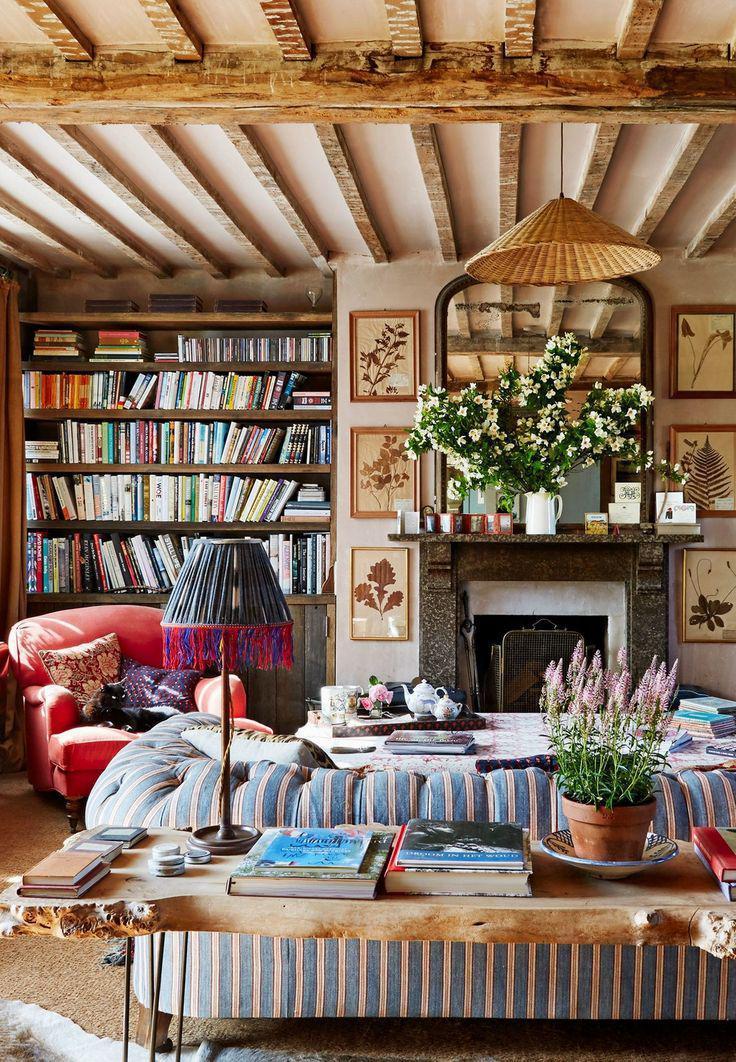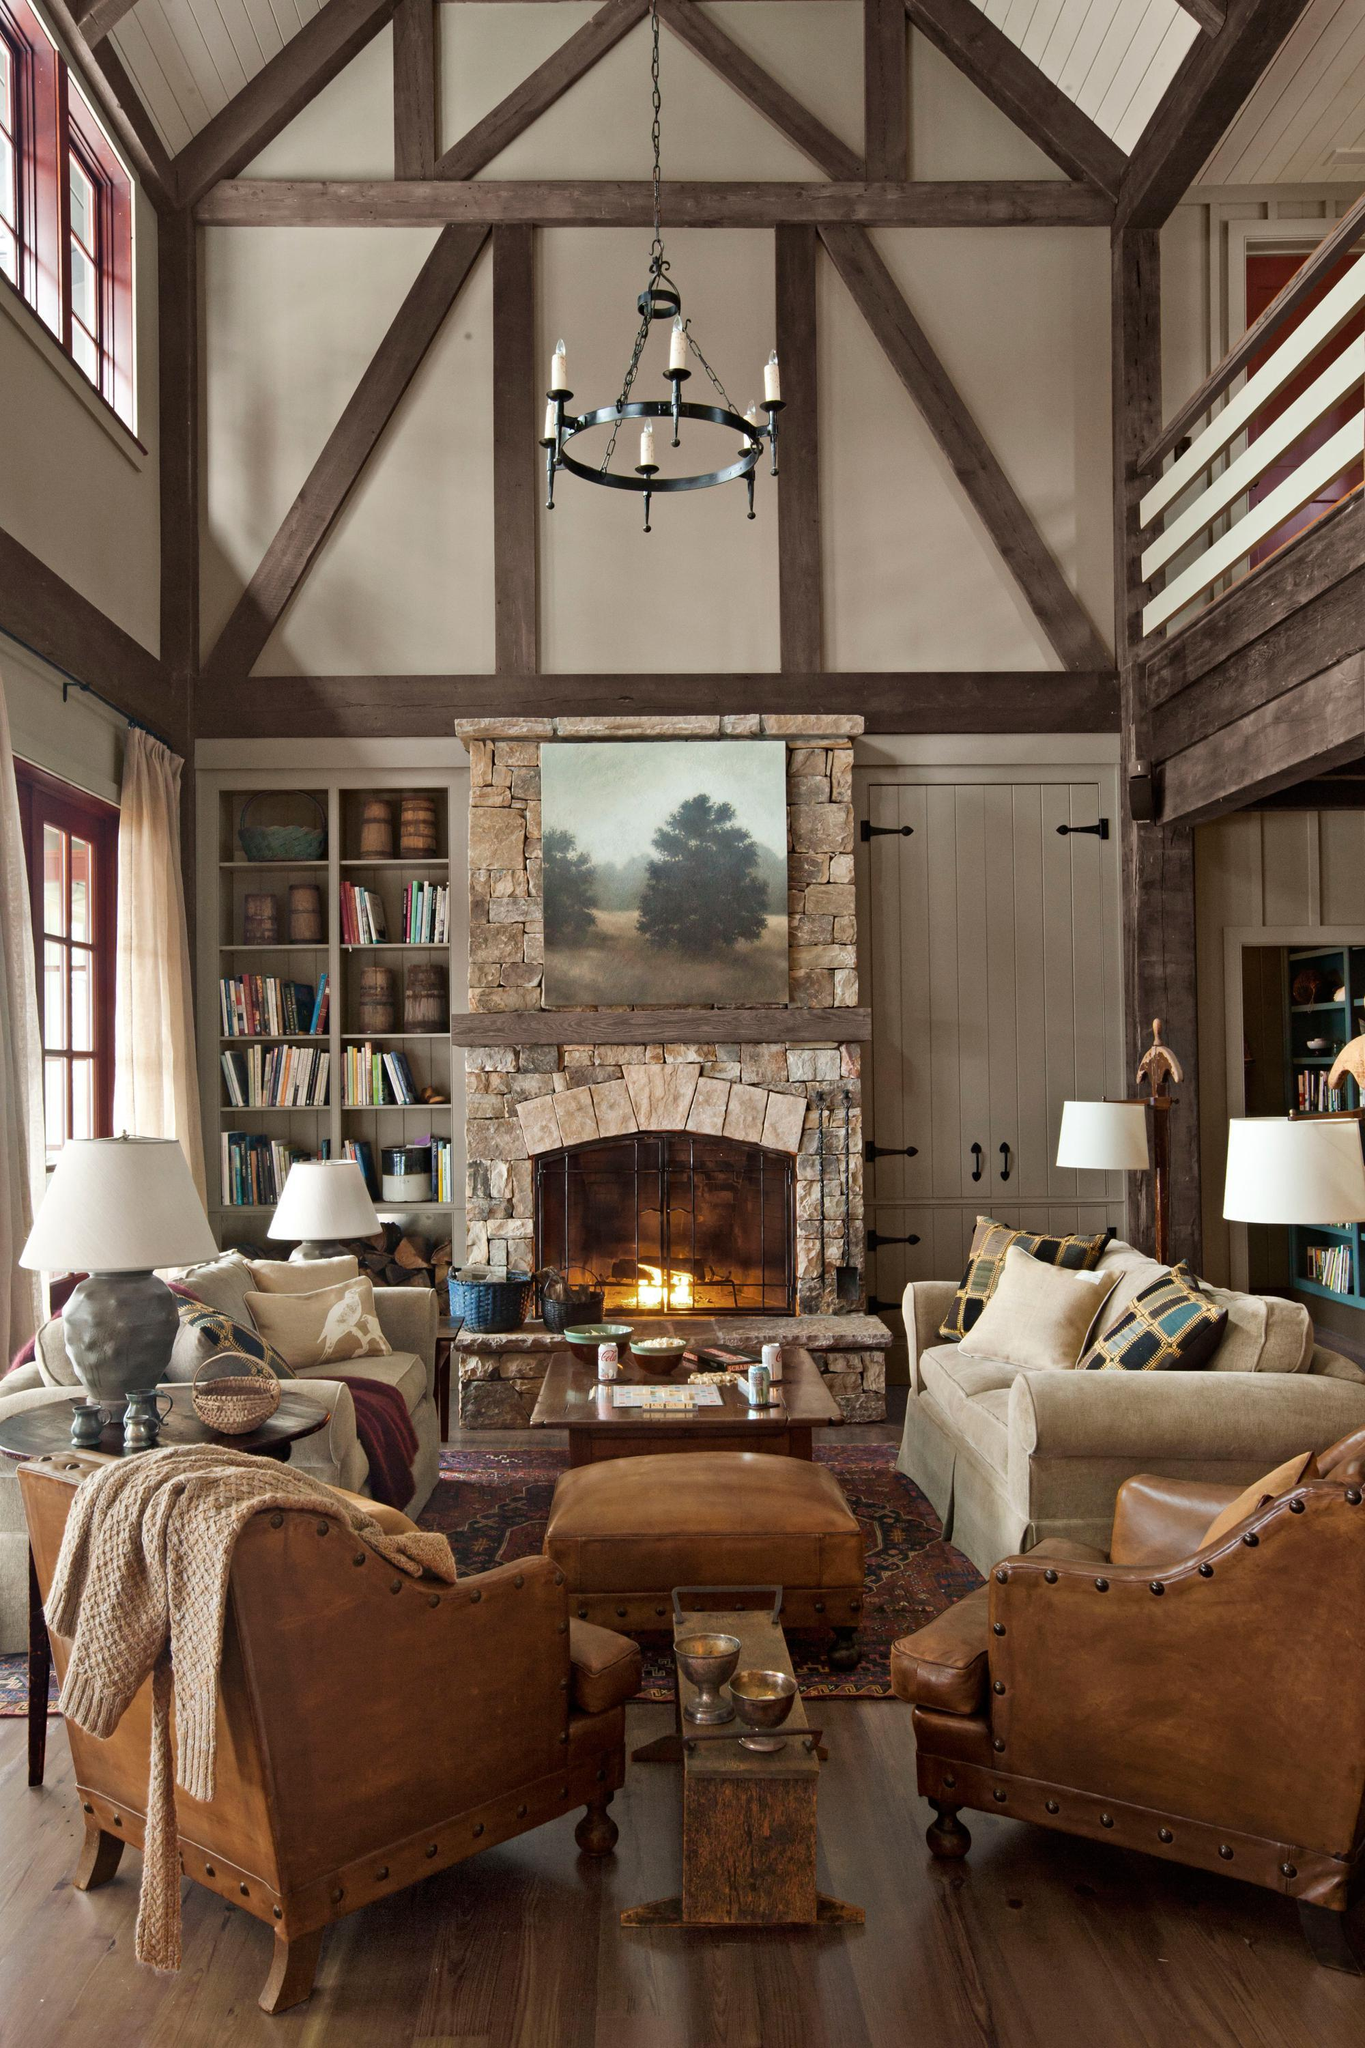The first image is the image on the left, the second image is the image on the right. For the images shown, is this caption "In at least one of the images there is a lamp suspended on a visible chain from the ceiling." true? Answer yes or no. Yes. The first image is the image on the left, the second image is the image on the right. Examine the images to the left and right. Is the description "There is a fireplace in at least one of the images." accurate? Answer yes or no. Yes. 